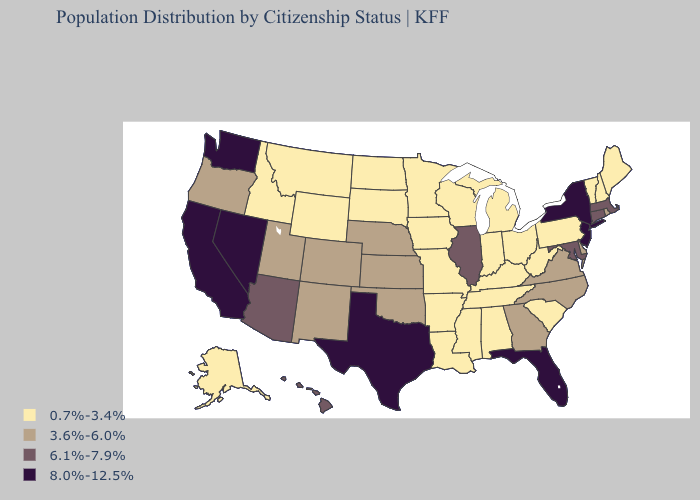What is the lowest value in the Northeast?
Write a very short answer. 0.7%-3.4%. Among the states that border Texas , does New Mexico have the lowest value?
Keep it brief. No. What is the value of Arizona?
Quick response, please. 6.1%-7.9%. What is the value of California?
Write a very short answer. 8.0%-12.5%. What is the highest value in the USA?
Write a very short answer. 8.0%-12.5%. Which states hav the highest value in the South?
Quick response, please. Florida, Texas. Name the states that have a value in the range 8.0%-12.5%?
Concise answer only. California, Florida, Nevada, New Jersey, New York, Texas, Washington. What is the lowest value in the Northeast?
Write a very short answer. 0.7%-3.4%. What is the value of Alabama?
Quick response, please. 0.7%-3.4%. What is the value of Nebraska?
Quick response, please. 3.6%-6.0%. Does New York have a lower value than Texas?
Quick response, please. No. Name the states that have a value in the range 0.7%-3.4%?
Short answer required. Alabama, Alaska, Arkansas, Idaho, Indiana, Iowa, Kentucky, Louisiana, Maine, Michigan, Minnesota, Mississippi, Missouri, Montana, New Hampshire, North Dakota, Ohio, Pennsylvania, South Carolina, South Dakota, Tennessee, Vermont, West Virginia, Wisconsin, Wyoming. What is the highest value in the West ?
Answer briefly. 8.0%-12.5%. Name the states that have a value in the range 8.0%-12.5%?
Keep it brief. California, Florida, Nevada, New Jersey, New York, Texas, Washington. 